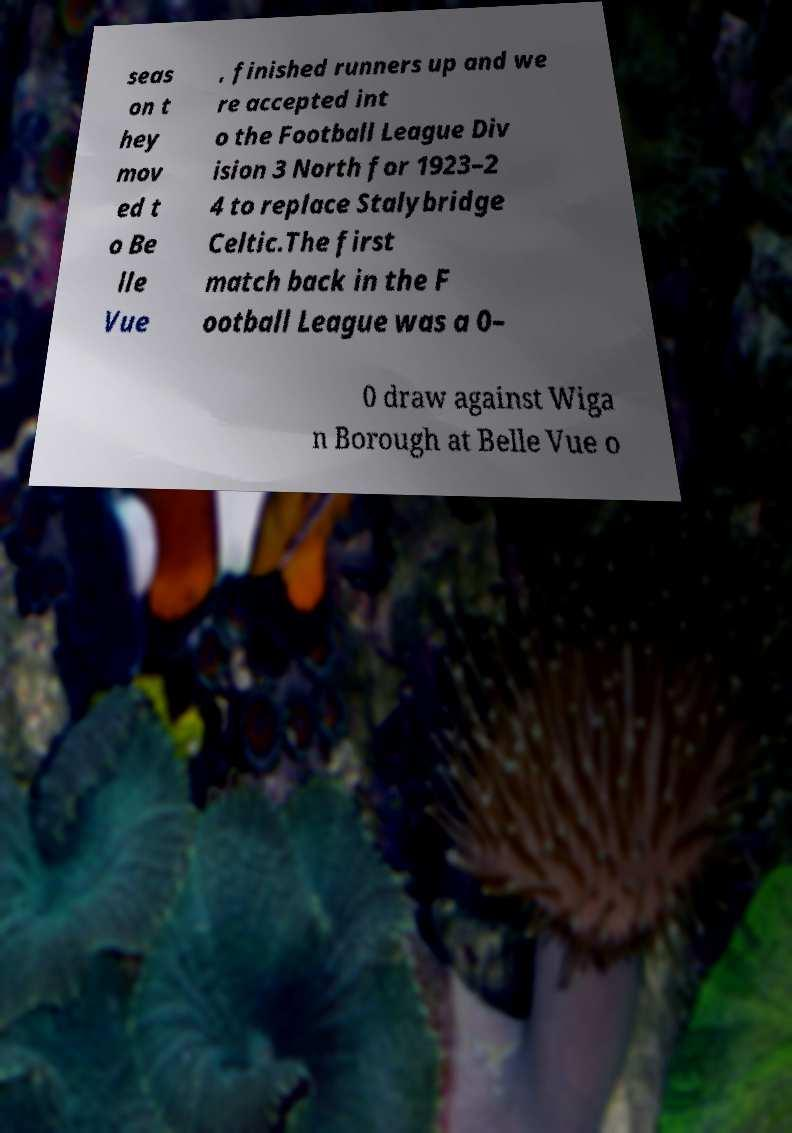What messages or text are displayed in this image? I need them in a readable, typed format. seas on t hey mov ed t o Be lle Vue , finished runners up and we re accepted int o the Football League Div ision 3 North for 1923–2 4 to replace Stalybridge Celtic.The first match back in the F ootball League was a 0– 0 draw against Wiga n Borough at Belle Vue o 